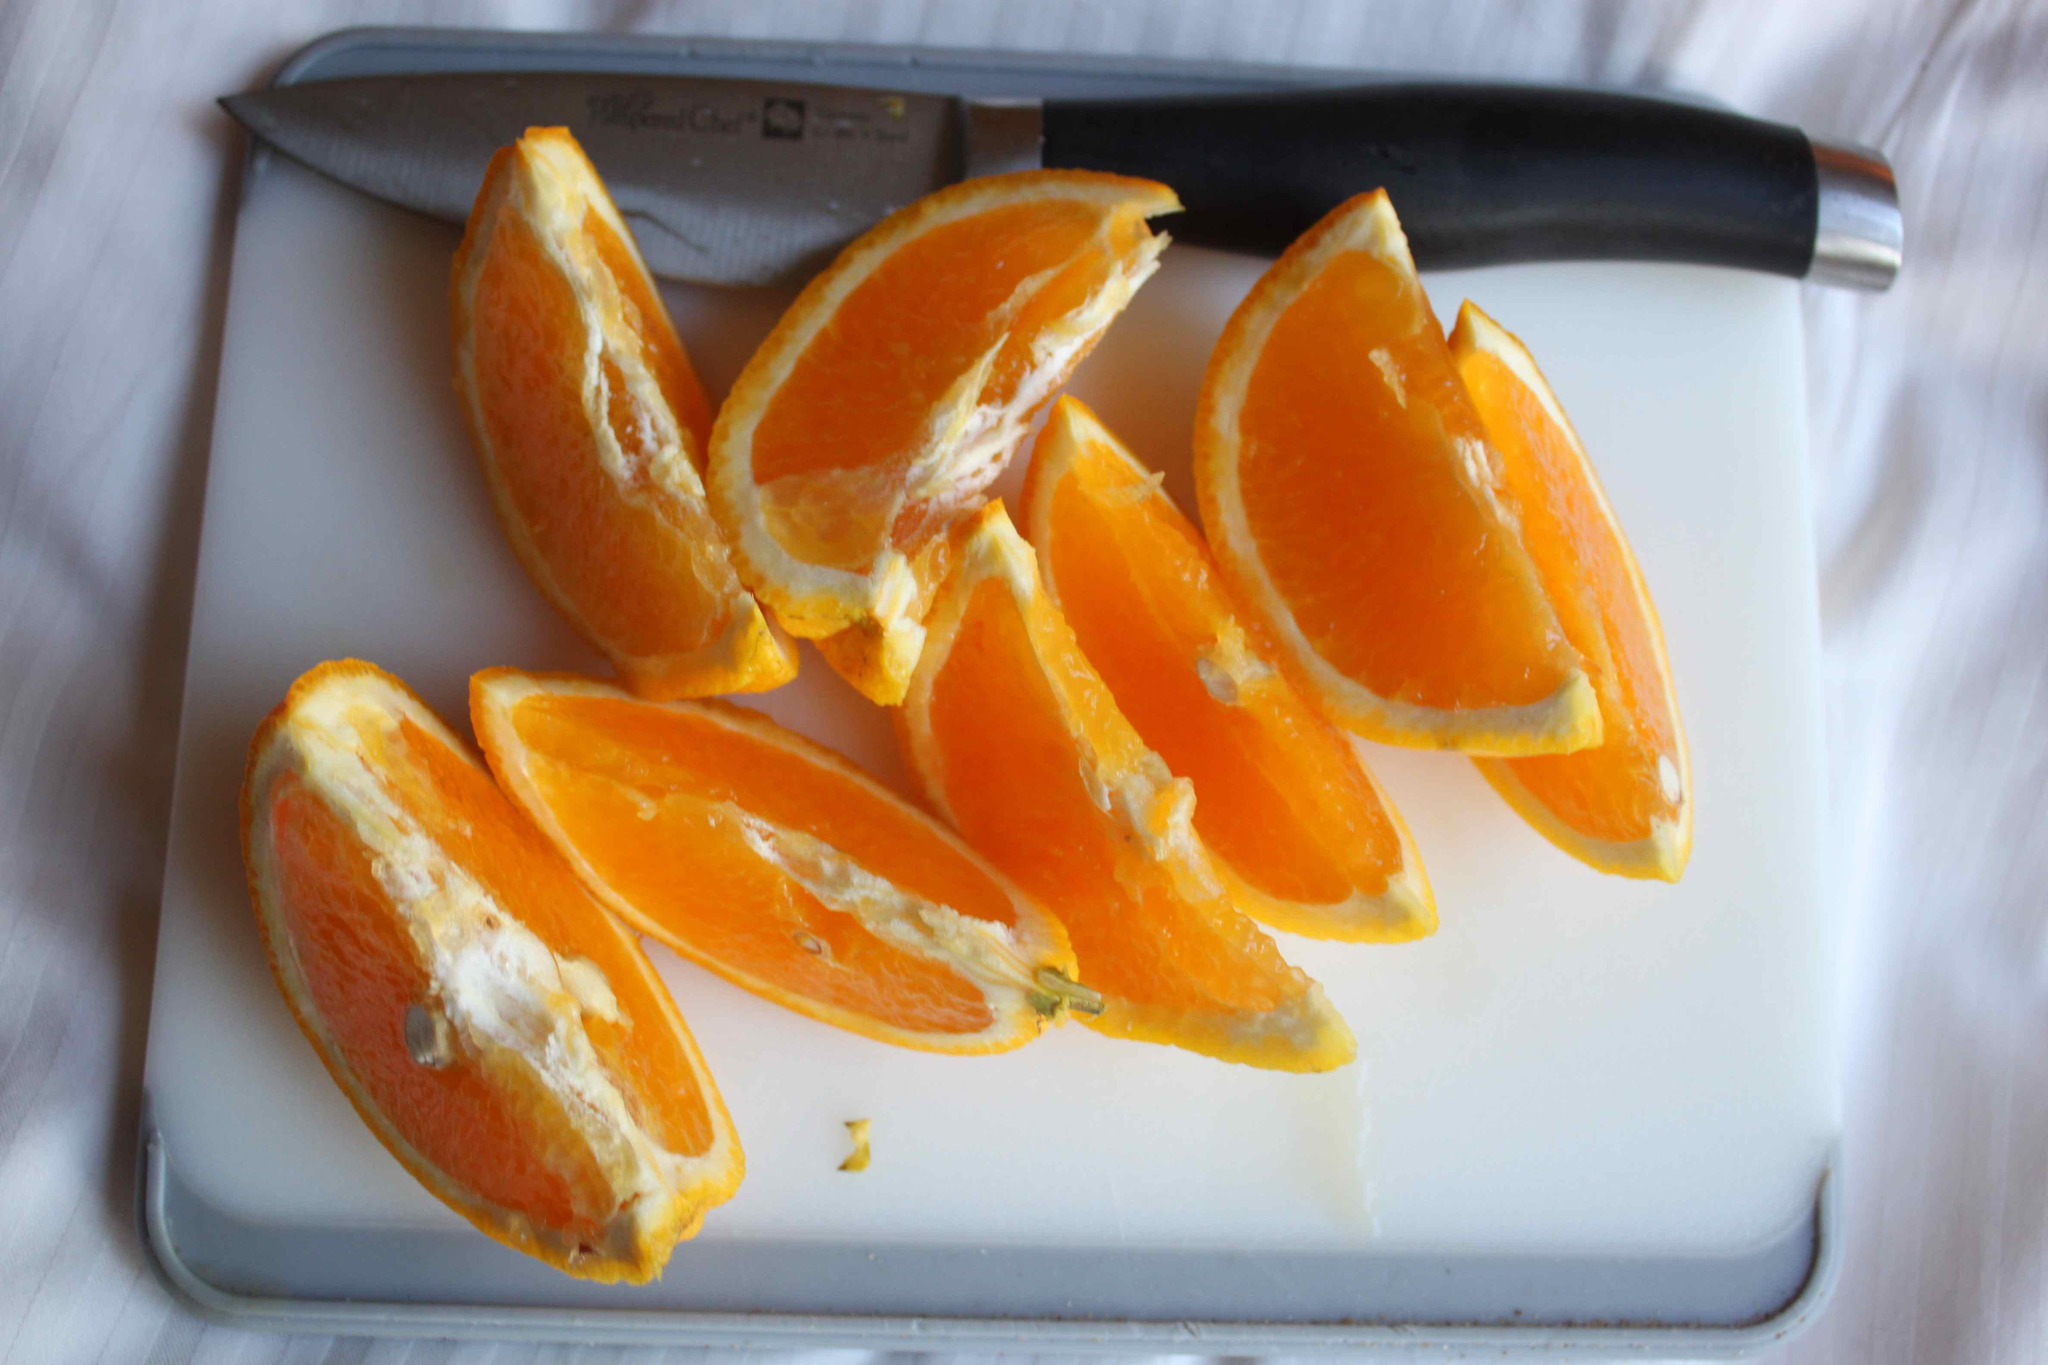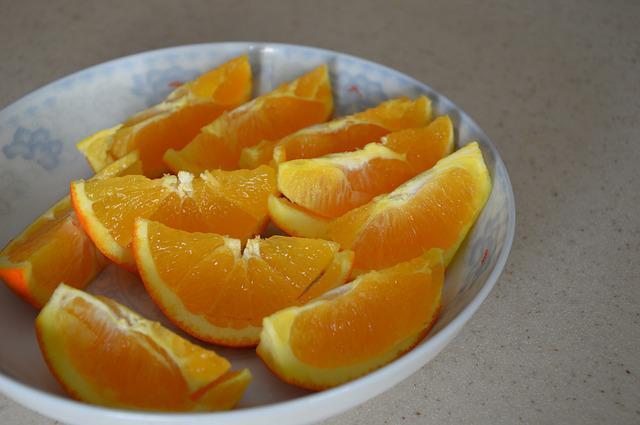The first image is the image on the left, the second image is the image on the right. Assess this claim about the two images: "In the left image, there is only 1 piece of fruit cut into halves.". Correct or not? Answer yes or no. No. The first image is the image on the left, the second image is the image on the right. Considering the images on both sides, is "There is at least one unsliced orange." valid? Answer yes or no. No. 